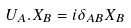Convert formula to latex. <formula><loc_0><loc_0><loc_500><loc_500>U _ { A } . X _ { B } = i \delta _ { A B } X _ { B }</formula> 